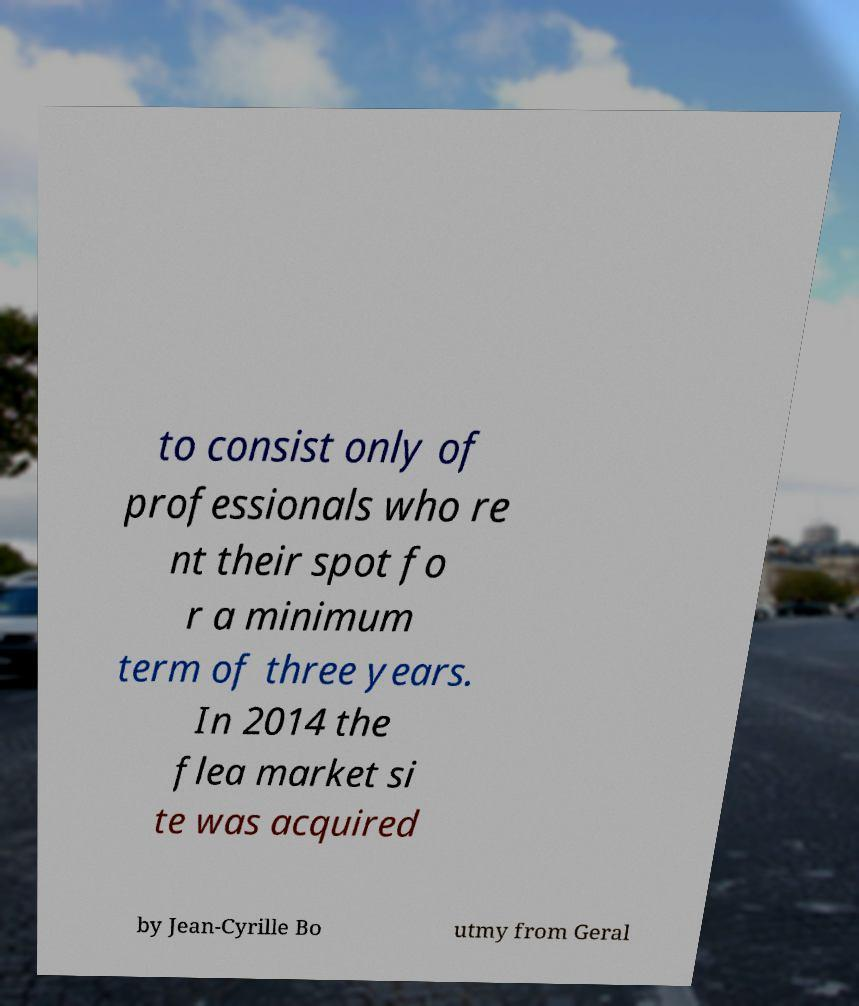I need the written content from this picture converted into text. Can you do that? to consist only of professionals who re nt their spot fo r a minimum term of three years. In 2014 the flea market si te was acquired by Jean-Cyrille Bo utmy from Geral 